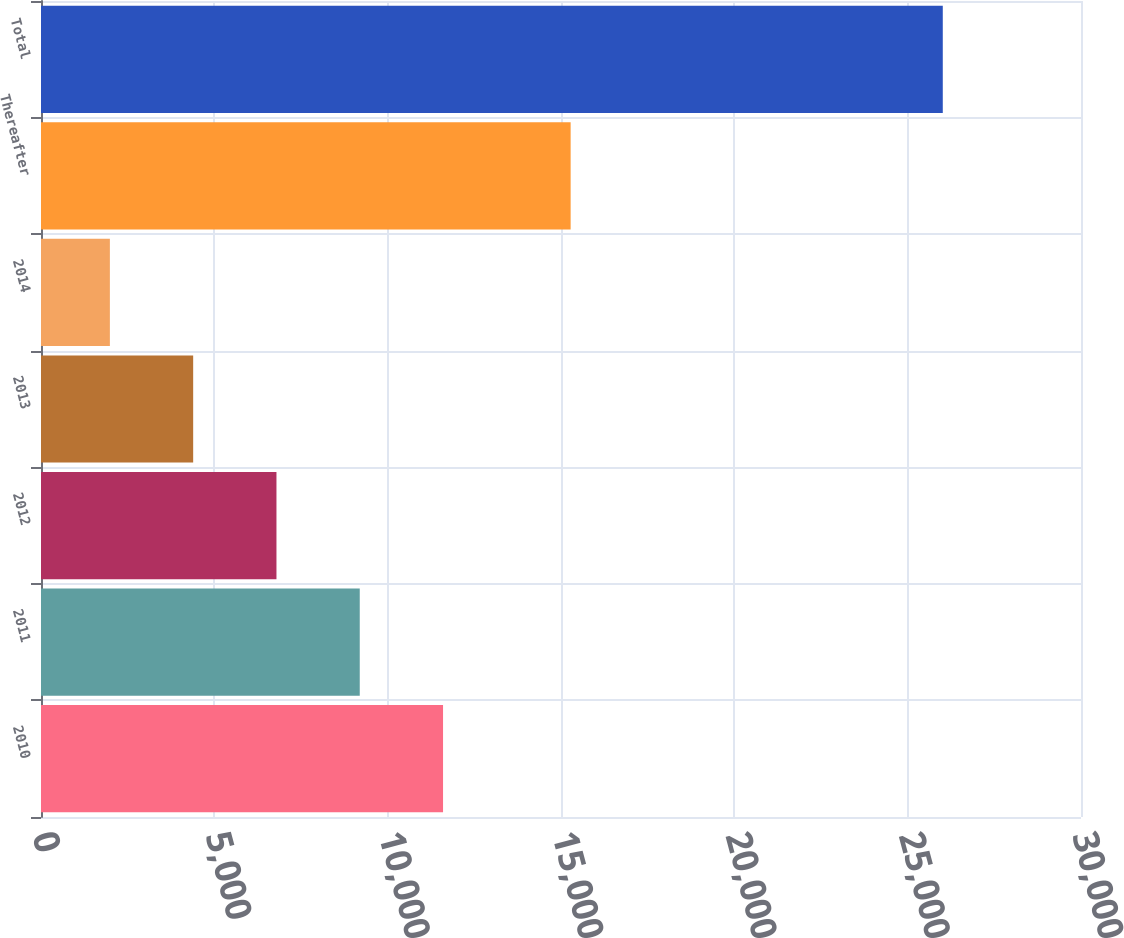Convert chart to OTSL. <chart><loc_0><loc_0><loc_500><loc_500><bar_chart><fcel>2010<fcel>2011<fcel>2012<fcel>2013<fcel>2014<fcel>Thereafter<fcel>Total<nl><fcel>11597.4<fcel>9194.8<fcel>6792.2<fcel>4389.6<fcel>1987<fcel>15278<fcel>26013<nl></chart> 